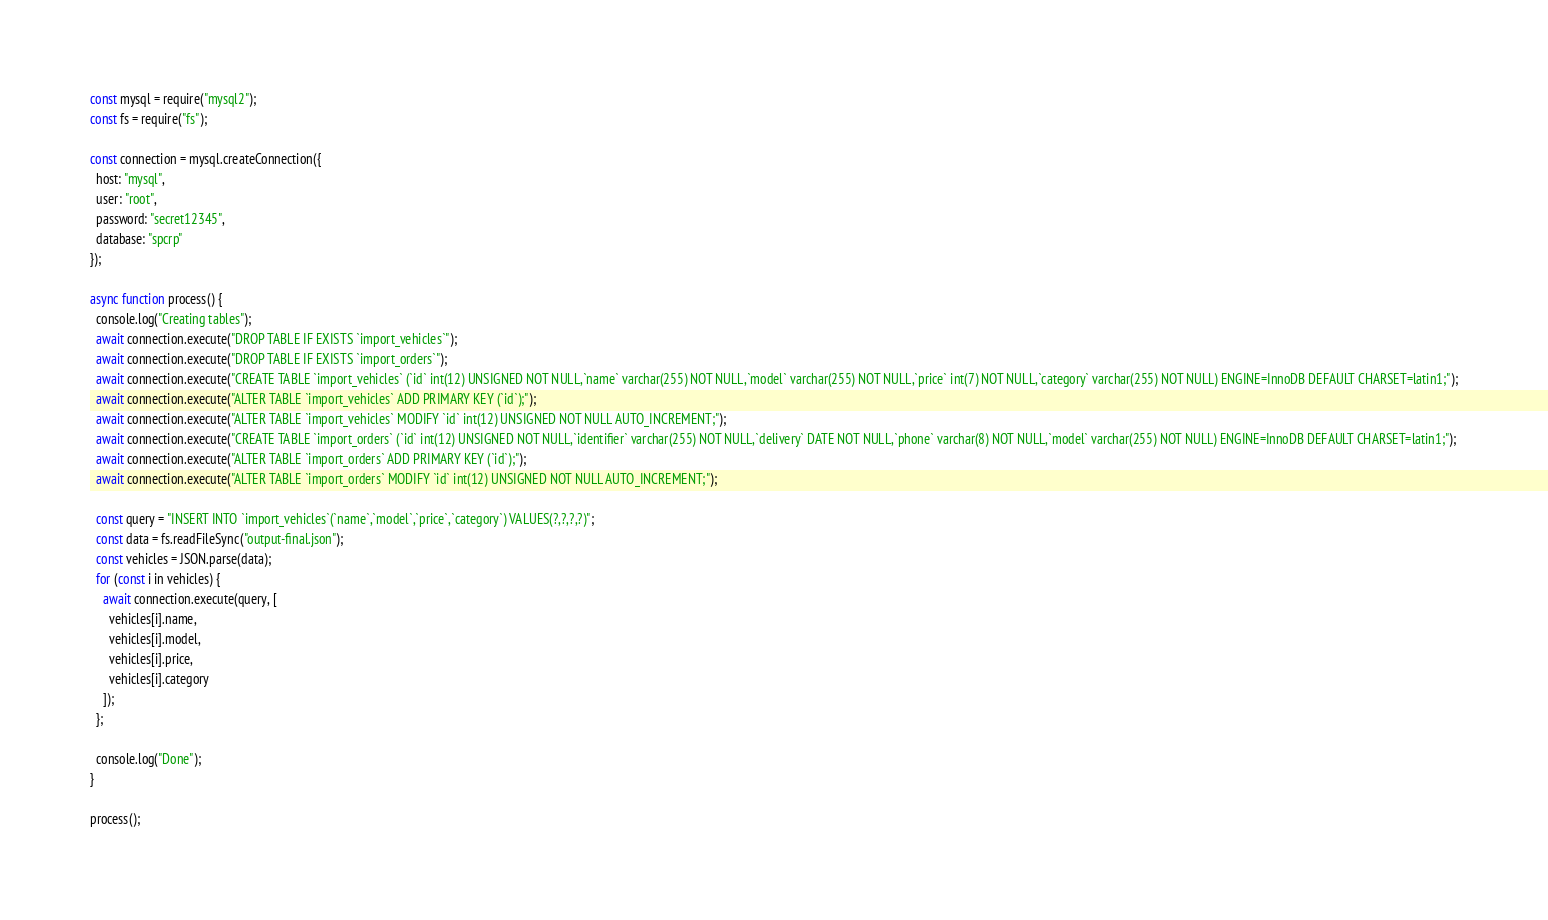Convert code to text. <code><loc_0><loc_0><loc_500><loc_500><_JavaScript_>const mysql = require("mysql2");
const fs = require("fs");

const connection = mysql.createConnection({
  host: "mysql",
  user: "root",
  password: "secret12345",
  database: "spcrp"
});

async function process() {
  console.log("Creating tables");
  await connection.execute("DROP TABLE IF EXISTS `import_vehicles`");
  await connection.execute("DROP TABLE IF EXISTS `import_orders`");
  await connection.execute("CREATE TABLE `import_vehicles` (`id` int(12) UNSIGNED NOT NULL,`name` varchar(255) NOT NULL,`model` varchar(255) NOT NULL,`price` int(7) NOT NULL,`category` varchar(255) NOT NULL) ENGINE=InnoDB DEFAULT CHARSET=latin1;");
  await connection.execute("ALTER TABLE `import_vehicles` ADD PRIMARY KEY (`id`);");
  await connection.execute("ALTER TABLE `import_vehicles` MODIFY `id` int(12) UNSIGNED NOT NULL AUTO_INCREMENT;");
  await connection.execute("CREATE TABLE `import_orders` (`id` int(12) UNSIGNED NOT NULL,`identifier` varchar(255) NOT NULL,`delivery` DATE NOT NULL,`phone` varchar(8) NOT NULL,`model` varchar(255) NOT NULL) ENGINE=InnoDB DEFAULT CHARSET=latin1;");
  await connection.execute("ALTER TABLE `import_orders` ADD PRIMARY KEY (`id`);");
  await connection.execute("ALTER TABLE `import_orders` MODIFY `id` int(12) UNSIGNED NOT NULL AUTO_INCREMENT;");
  
  const query = "INSERT INTO `import_vehicles`(`name`,`model`,`price`,`category`) VALUES(?,?,?,?)";
  const data = fs.readFileSync("output-final.json");
  const vehicles = JSON.parse(data);
  for (const i in vehicles) {
    await connection.execute(query, [
      vehicles[i].name,
      vehicles[i].model,
      vehicles[i].price,
      vehicles[i].category
    ]);
  };

  console.log("Done");
}

process();</code> 